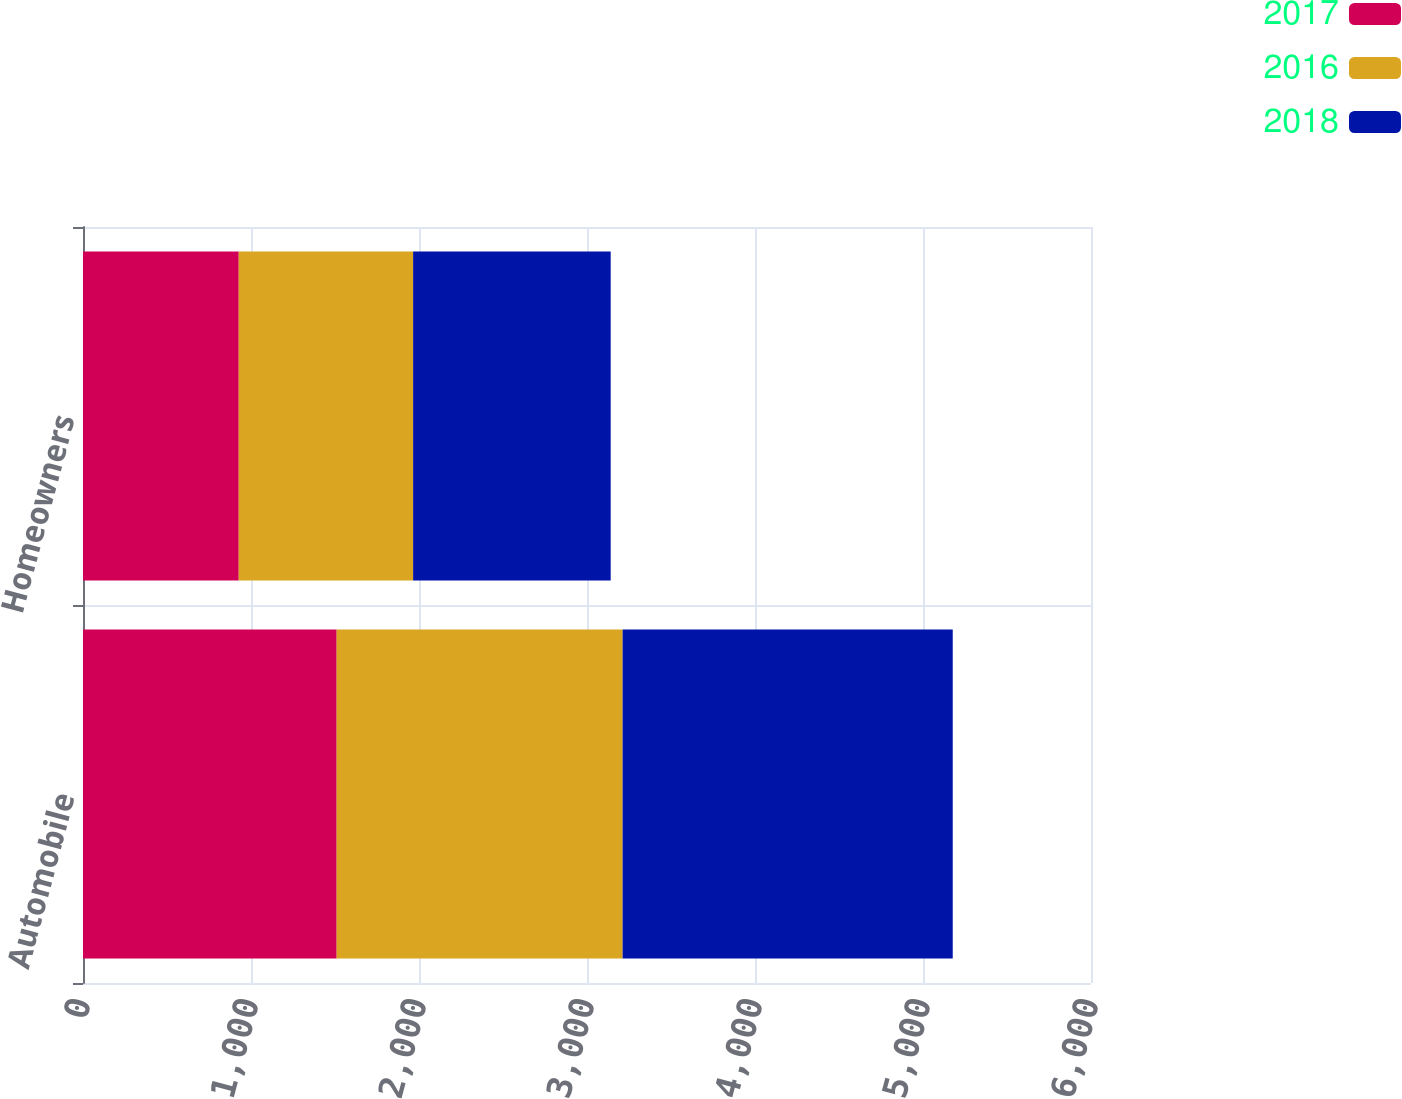Convert chart. <chart><loc_0><loc_0><loc_500><loc_500><stacked_bar_chart><ecel><fcel>Automobile<fcel>Homeowners<nl><fcel>2017<fcel>1510<fcel>927<nl><fcel>2016<fcel>1702<fcel>1038<nl><fcel>2018<fcel>1965<fcel>1176<nl></chart> 